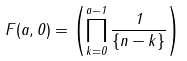Convert formula to latex. <formula><loc_0><loc_0><loc_500><loc_500>F ( a , 0 ) = \left ( \prod _ { k = 0 } ^ { a - 1 } \frac { 1 } { \{ n - k \} } \right )</formula> 